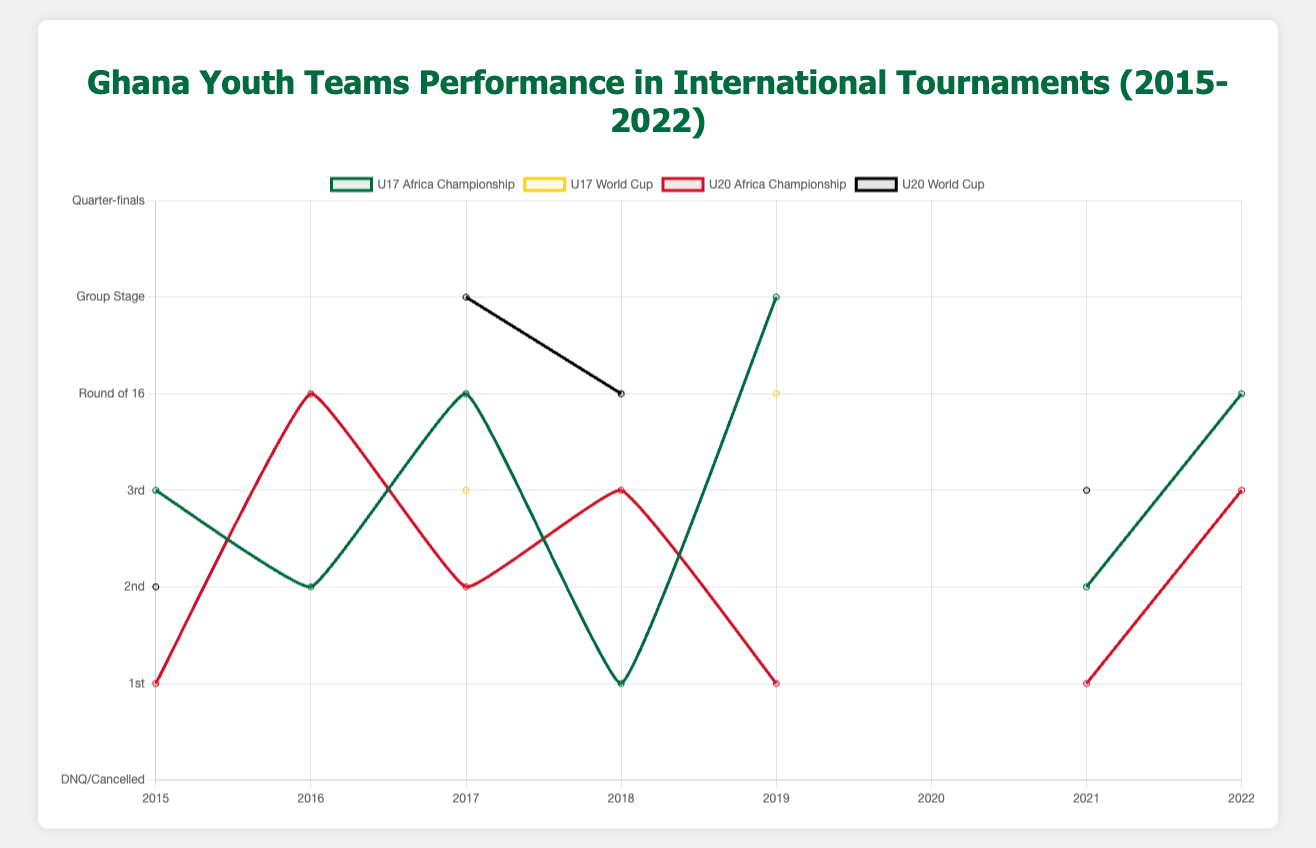How did the Ghana U20 Africa Championship team perform in 2015 compared to 2019? In 2015, the U20 Africa Championship team finished in 1st place and in 2019 they also finished in 1st place. This can be seen distinctly in the chart where the lines corresponding to 2015 and 2019 both peak at the top for the U20 Africa Championship.
Answer: Equal performance: 1st place in both years What was the trend in the Ghana U17 Africa Championship from 2015 to 2018? The U17 Africa Championship performance shows an increasing trend from 3rd place in 2015 to 1st place in 2018. This is displayed by a consistent rising in the green line from 2015 to 2018.
Answer: Improved performance, reaching 1st place in 2018 Which year did the Ghana U20 World Cup team achieve its best performance, and what was the outcome? The Ghana U20 World Cup team achieved its best performance in 2015, finishing in 2nd place. The black line peaks at its highest in 2015.
Answer: 2015, 2nd place Compare the U17 Africa Championship performance with the U17 World Cup performance in 2019. In 2019, the U17 Africa Championship team finished in 5th place, while the U17 World Cup team reached the quarter-finals. This is indicated by a higher position of the yellow line compared to the green one in 2019.
Answer: U17 Africa Championship: 5th place, U17 World Cup: Quarter-finals Was there any year when both U17 and U20 World Cup tournaments were cancelled? Yes, both the U17 and U20 World Cup tournaments were cancelled in 2020 due to the pandemic, as shown by the lack of data points for those categories in that year.
Answer: 2020 Calculate the average performance of the Ghana U17 Africa Championship team from 2015 to 2019. The performances from 2015 to 2019 are 3, 2, 4, 1, 5 respectively. The sum of these values is 15, and there are 5 observations. So, the average performance is 15/5 = 3.
Answer: Average: 3 Did the Ghana U20 Africa Championship and U20 World Cup teams ever reach the same stage in any year? Yes, in 2017 both teams had a similar pattern where the U20 Africa Championship team finished 2nd and the U20 World Cup team reached the group stage, both indicating a strong but not top performance. Additionally, in 2019, although the U20 World Cup was not played, the U20 Africa Championship finished 1st consistently similar to their top performances in earlier years like 2015.
Answer: No exact same stage but close in 2017 Identify the year with the most inconsistent performance between U17 Africa Championship and U17 World Cup. The year 2019 stands out as inconsistent for the U17 categories, where the U17 Africa Championship team placed 5th, whereas the U17 World Cup team reached the quarter-finals. This is a visible large discrepancy in the chart.
Answer: 2019 What visual trend can you notice for the U20 Africa Championship from 2015 to 2022? There is a noticeable fluctuation in performance with peaks in 2015, 2019, and 2021 all at 1st place, with dips in between. The red line goes up and down, showing periods of high performance followed by lower results.
Answer: Fluctuating performance with multiple peaks What was the combined total number of 1st place finishes for the U17 and U20 Africa Championship from 2015 to 2022? The U17 Africa Championship had 1st place finishes in 2018, and the U20 Africa Championship had 1st place finishes in 2015, 2019, and 2021. Summing these gives us a total of 4 first-place finishes.
Answer: Total: 4 